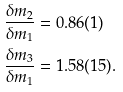<formula> <loc_0><loc_0><loc_500><loc_500>\frac { \delta m _ { 2 } } { \delta m _ { 1 } } & = 0 . 8 6 ( 1 ) \\ \frac { \delta m _ { 3 } } { \delta m _ { 1 } } & = 1 . 5 8 ( 1 5 ) .</formula> 